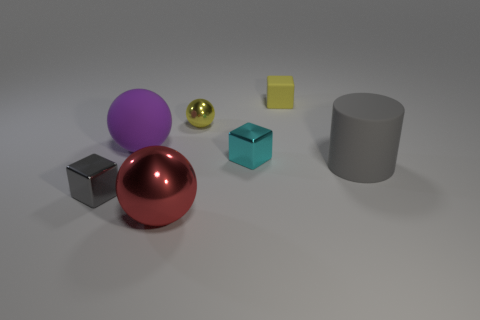Add 1 big brown shiny objects. How many objects exist? 8 Subtract all blocks. How many objects are left? 4 Add 2 gray things. How many gray things exist? 4 Subtract 0 blue blocks. How many objects are left? 7 Subtract all purple things. Subtract all purple rubber balls. How many objects are left? 5 Add 1 tiny yellow rubber objects. How many tiny yellow rubber objects are left? 2 